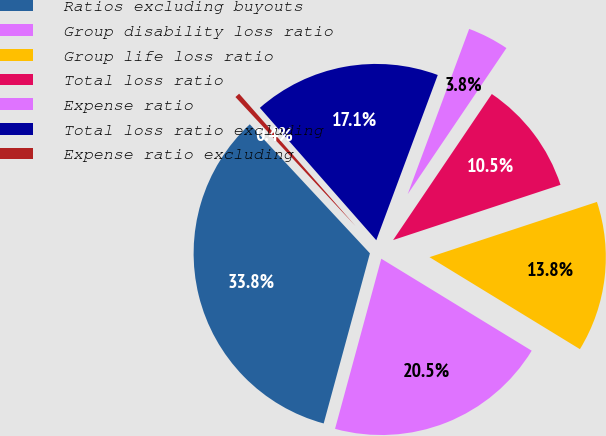Convert chart. <chart><loc_0><loc_0><loc_500><loc_500><pie_chart><fcel>Ratios excluding buyouts<fcel>Group disability loss ratio<fcel>Group life loss ratio<fcel>Total loss ratio<fcel>Expense ratio<fcel>Total loss ratio excluding<fcel>Expense ratio excluding<nl><fcel>33.85%<fcel>20.49%<fcel>13.81%<fcel>10.47%<fcel>3.79%<fcel>17.15%<fcel>0.45%<nl></chart> 